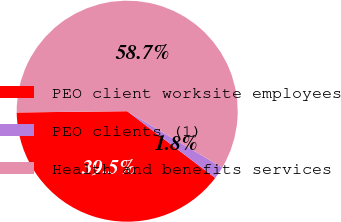Convert chart. <chart><loc_0><loc_0><loc_500><loc_500><pie_chart><fcel>PEO client worksite employees<fcel>PEO clients (1)<fcel>Health and benefits services<nl><fcel>39.49%<fcel>1.81%<fcel>58.7%<nl></chart> 